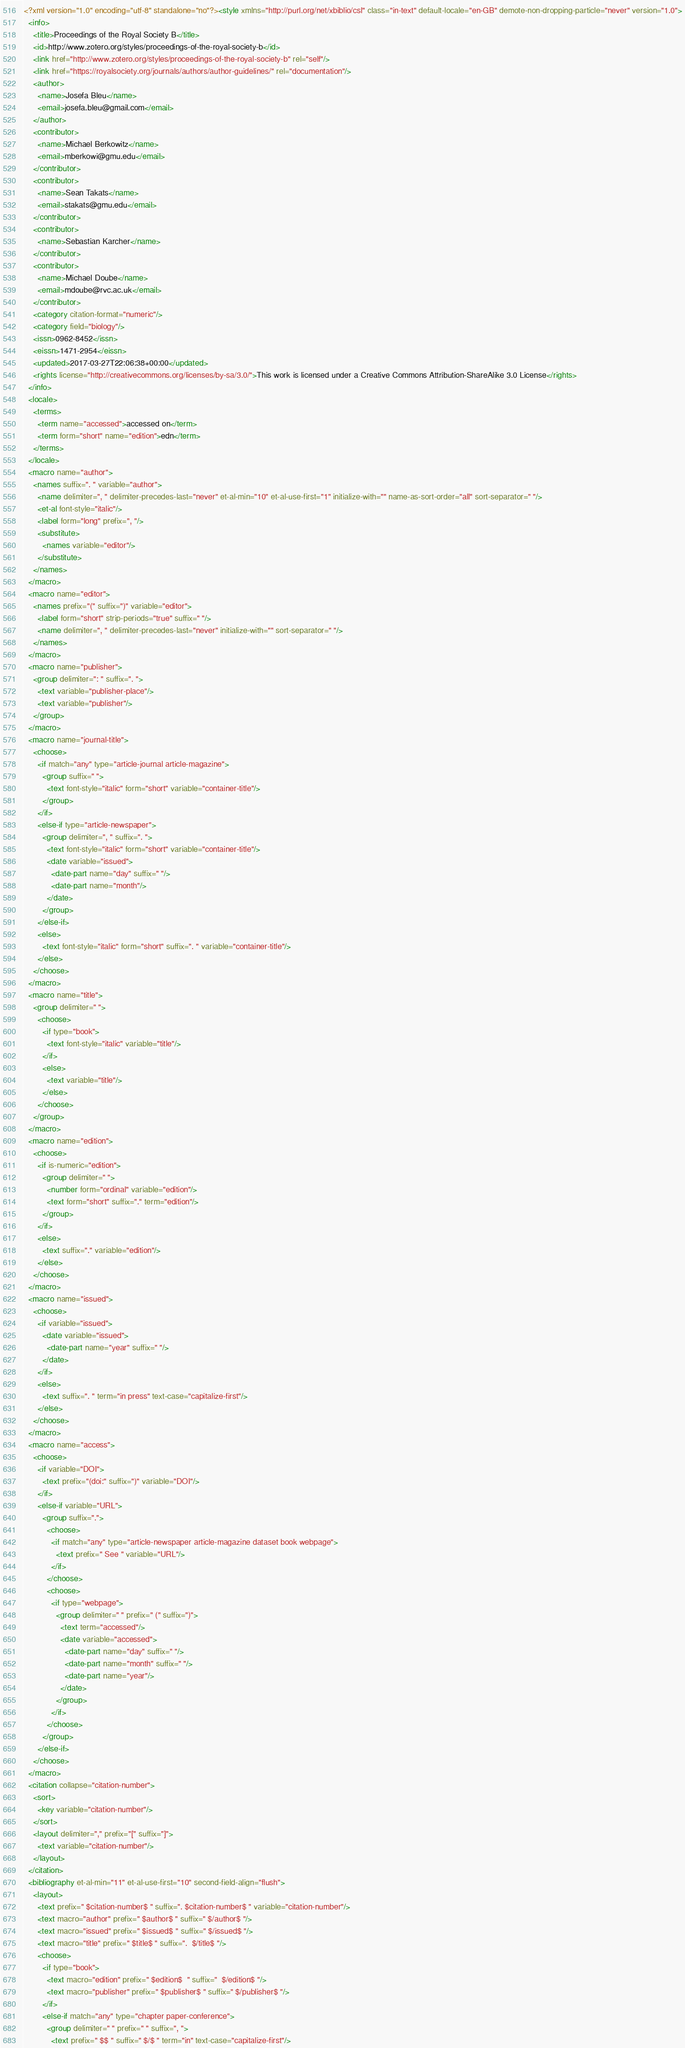Convert code to text. <code><loc_0><loc_0><loc_500><loc_500><_XML_><?xml version="1.0" encoding="utf-8" standalone="no"?><style xmlns="http://purl.org/net/xbiblio/csl" class="in-text" default-locale="en-GB" demote-non-dropping-particle="never" version="1.0">
  <info>
    <title>Proceedings of the Royal Society B</title>
    <id>http://www.zotero.org/styles/proceedings-of-the-royal-society-b</id>
    <link href="http://www.zotero.org/styles/proceedings-of-the-royal-society-b" rel="self"/>
    <link href="https://royalsociety.org/journals/authors/author-guidelines/" rel="documentation"/>
    <author>
      <name>Josefa Bleu</name>
      <email>josefa.bleu@gmail.com</email>
    </author>
    <contributor>
      <name>Michael Berkowitz</name>
      <email>mberkowi@gmu.edu</email>
    </contributor>
    <contributor>
      <name>Sean Takats</name>
      <email>stakats@gmu.edu</email>
    </contributor>
    <contributor>
      <name>Sebastian Karcher</name>
    </contributor>
    <contributor>
      <name>Michael Doube</name>
      <email>mdoube@rvc.ac.uk</email>
    </contributor>
    <category citation-format="numeric"/>
    <category field="biology"/>
    <issn>0962-8452</issn>
    <eissn>1471-2954</eissn>
    <updated>2017-03-27T22:06:38+00:00</updated>
    <rights license="http://creativecommons.org/licenses/by-sa/3.0/">This work is licensed under a Creative Commons Attribution-ShareAlike 3.0 License</rights>
  </info>
  <locale>
    <terms>
      <term name="accessed">accessed on</term>
      <term form="short" name="edition">edn</term>
    </terms>
  </locale>
  <macro name="author">
    <names suffix=". " variable="author">
      <name delimiter=", " delimiter-precedes-last="never" et-al-min="10" et-al-use-first="1" initialize-with="" name-as-sort-order="all" sort-separator=" "/>
      <et-al font-style="italic"/>
      <label form="long" prefix=", "/>
      <substitute>
        <names variable="editor"/>
      </substitute>
    </names>
  </macro>
  <macro name="editor">
    <names prefix="(" suffix=")" variable="editor">
      <label form="short" strip-periods="true" suffix=" "/>
      <name delimiter=", " delimiter-precedes-last="never" initialize-with="" sort-separator=" "/>
    </names>
  </macro>
  <macro name="publisher">
    <group delimiter=": " suffix=". ">
      <text variable="publisher-place"/>
      <text variable="publisher"/>
    </group>
  </macro>
  <macro name="journal-title">
    <choose>
      <if match="any" type="article-journal article-magazine">
        <group suffix=" ">
          <text font-style="italic" form="short" variable="container-title"/>
        </group>
      </if>
      <else-if type="article-newspaper">
        <group delimiter=", " suffix=". ">
          <text font-style="italic" form="short" variable="container-title"/>
          <date variable="issued">
            <date-part name="day" suffix=" "/>
            <date-part name="month"/>
          </date>
        </group>
      </else-if>
      <else>
        <text font-style="italic" form="short" suffix=". " variable="container-title"/>
      </else>
    </choose>
  </macro>
  <macro name="title">
    <group delimiter=" ">
      <choose>
        <if type="book">
          <text font-style="italic" variable="title"/>
        </if>
        <else>
          <text variable="title"/>
        </else>
      </choose>
    </group>
  </macro>
  <macro name="edition">
    <choose>
      <if is-numeric="edition">
        <group delimiter=" ">
          <number form="ordinal" variable="edition"/>
          <text form="short" suffix="." term="edition"/>
        </group>
      </if>
      <else>
        <text suffix="." variable="edition"/>
      </else>
    </choose>
  </macro>
  <macro name="issued">
    <choose>
      <if variable="issued">
        <date variable="issued">
          <date-part name="year" suffix=" "/>
        </date>
      </if>
      <else>
        <text suffix=". " term="in press" text-case="capitalize-first"/>
      </else>
    </choose>
  </macro>
  <macro name="access">
    <choose>
      <if variable="DOI">
        <text prefix="(doi:" suffix=")" variable="DOI"/>
      </if>
      <else-if variable="URL">
        <group suffix=".">
          <choose>
            <if match="any" type="article-newspaper article-magazine dataset book webpage">
              <text prefix=" See " variable="URL"/>
            </if>
          </choose>
          <choose>
            <if type="webpage">
              <group delimiter=" " prefix=" (" suffix=")">
                <text term="accessed"/>
                <date variable="accessed">
                  <date-part name="day" suffix=" "/>
                  <date-part name="month" suffix=" "/>
                  <date-part name="year"/>
                </date>
              </group>
            </if>
          </choose>
        </group>
      </else-if>
    </choose>
  </macro>
  <citation collapse="citation-number">
    <sort>
      <key variable="citation-number"/>
    </sort>
    <layout delimiter="," prefix="[" suffix="]">
      <text variable="citation-number"/>
    </layout>
  </citation>
  <bibliography et-al-min="11" et-al-use-first="10" second-field-align="flush">
    <layout>
      <text prefix=" $citation-number$ " suffix=". $citation-number$ " variable="citation-number"/>
      <text macro="author" prefix=" $author$ " suffix=" $/author$ "/>
      <text macro="issued" prefix=" $issued$ " suffix=" $/issued$ "/>
      <text macro="title" prefix=" $title$ " suffix=".  $/title$ "/>
      <choose>
        <if type="book">
          <text macro="edition" prefix=" $edition$  " suffix="  $/edition$ "/>
          <text macro="publisher" prefix=" $publisher$ " suffix=" $/publisher$ "/>
        </if>
        <else-if match="any" type="chapter paper-conference">
          <group delimiter=" " prefix=" " suffix=", ">
            <text prefix=" $$ " suffix=" $/$ " term="in" text-case="capitalize-first"/></code> 